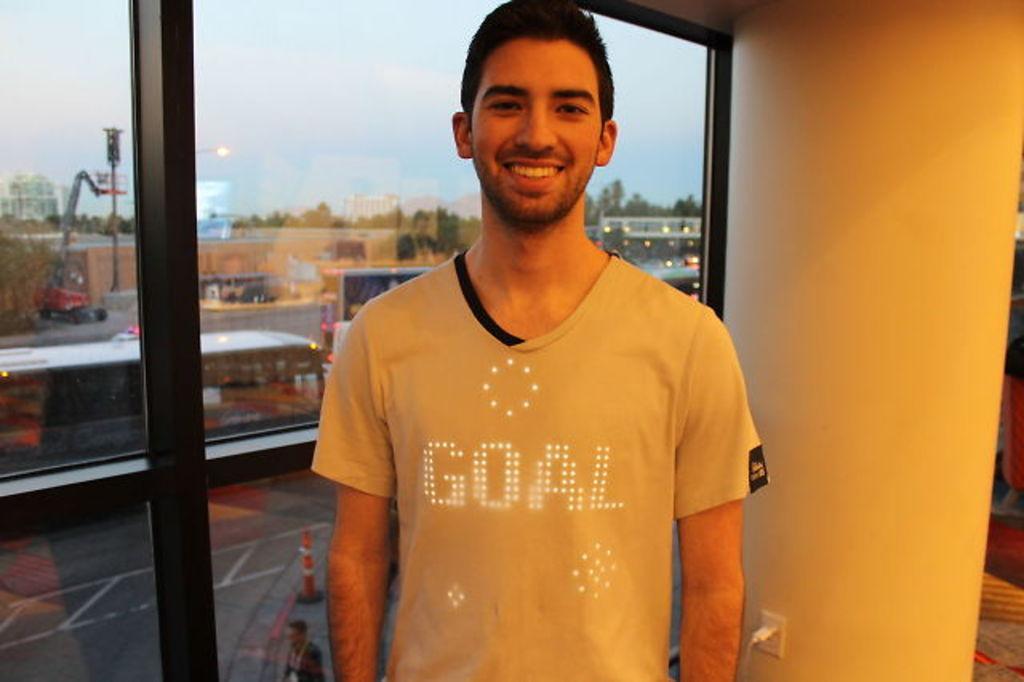Please provide a concise description of this image. In the center of the image we can see a man standing and smiling. On the right there is a pillar. In the background there is a glass and we can see reflection of vehicles, buildings, trees and sky through the glass. 